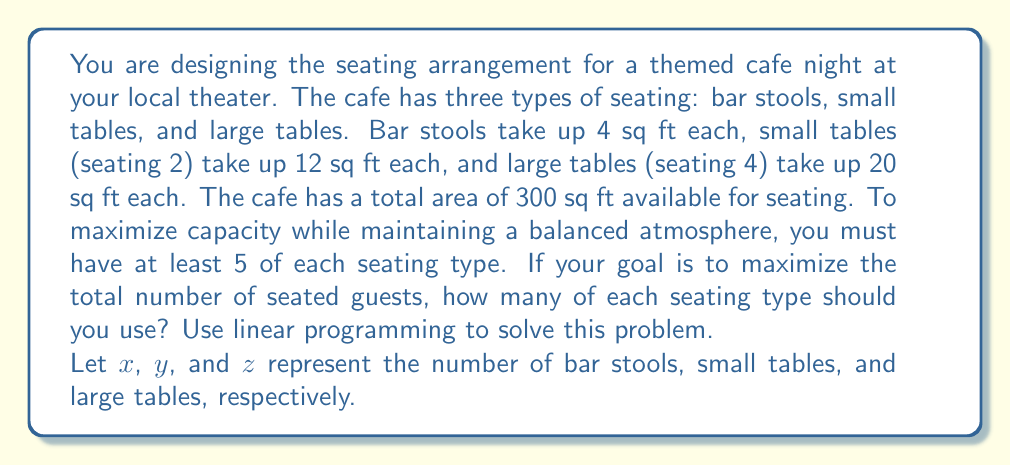Show me your answer to this math problem. To solve this problem using linear programming, we need to set up the objective function and constraints:

1. Objective function (maximize total seated guests):
   $$ \text{Maximize } f(x,y,z) = x + 2y + 4z $$

2. Constraints:
   a. Area constraint: $4x + 12y + 20z \leq 300$
   b. Minimum seating requirements: $x \geq 5$, $y \geq 5$, $z \geq 5$
   c. Non-negativity: $x, y, z \geq 0$

3. Set up the linear program:
   $$ \begin{align*}
   \text{Maximize } & x + 2y + 4z \\
   \text{Subject to: } & 4x + 12y + 20z \leq 300 \\
   & x \geq 5 \\
   & y \geq 5 \\
   & z \geq 5 \\
   & x, y, z \geq 0 \text{ and integer}
   \end{align*} $$

4. Solve using the simplex method or a linear programming solver:
   The optimal solution is $x = 25$, $y = 5$, $z = 10$

5. Verify the solution:
   - Area used: $4(25) + 12(5) + 20(10) = 100 + 60 + 200 = 360$ sq ft (meets constraint)
   - Minimum seating requirements are met
   - Total seated guests: $25 + 2(5) + 4(10) = 25 + 10 + 40 = 75$

Therefore, the optimal seating arrangement is 25 bar stools, 5 small tables, and 10 large tables, accommodating a total of 75 guests.
Answer: 25 bar stools, 5 small tables, 10 large tables 